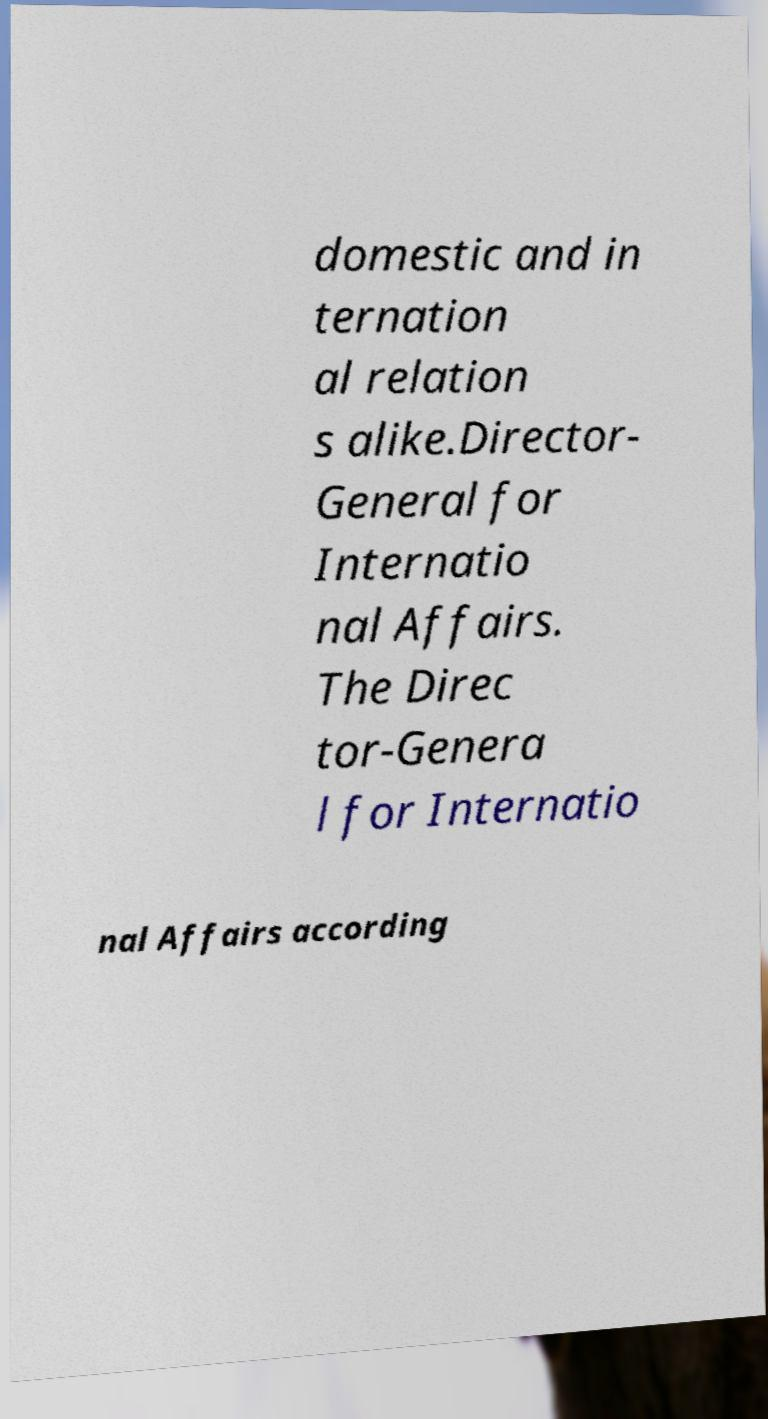Please read and relay the text visible in this image. What does it say? domestic and in ternation al relation s alike.Director- General for Internatio nal Affairs. The Direc tor-Genera l for Internatio nal Affairs according 